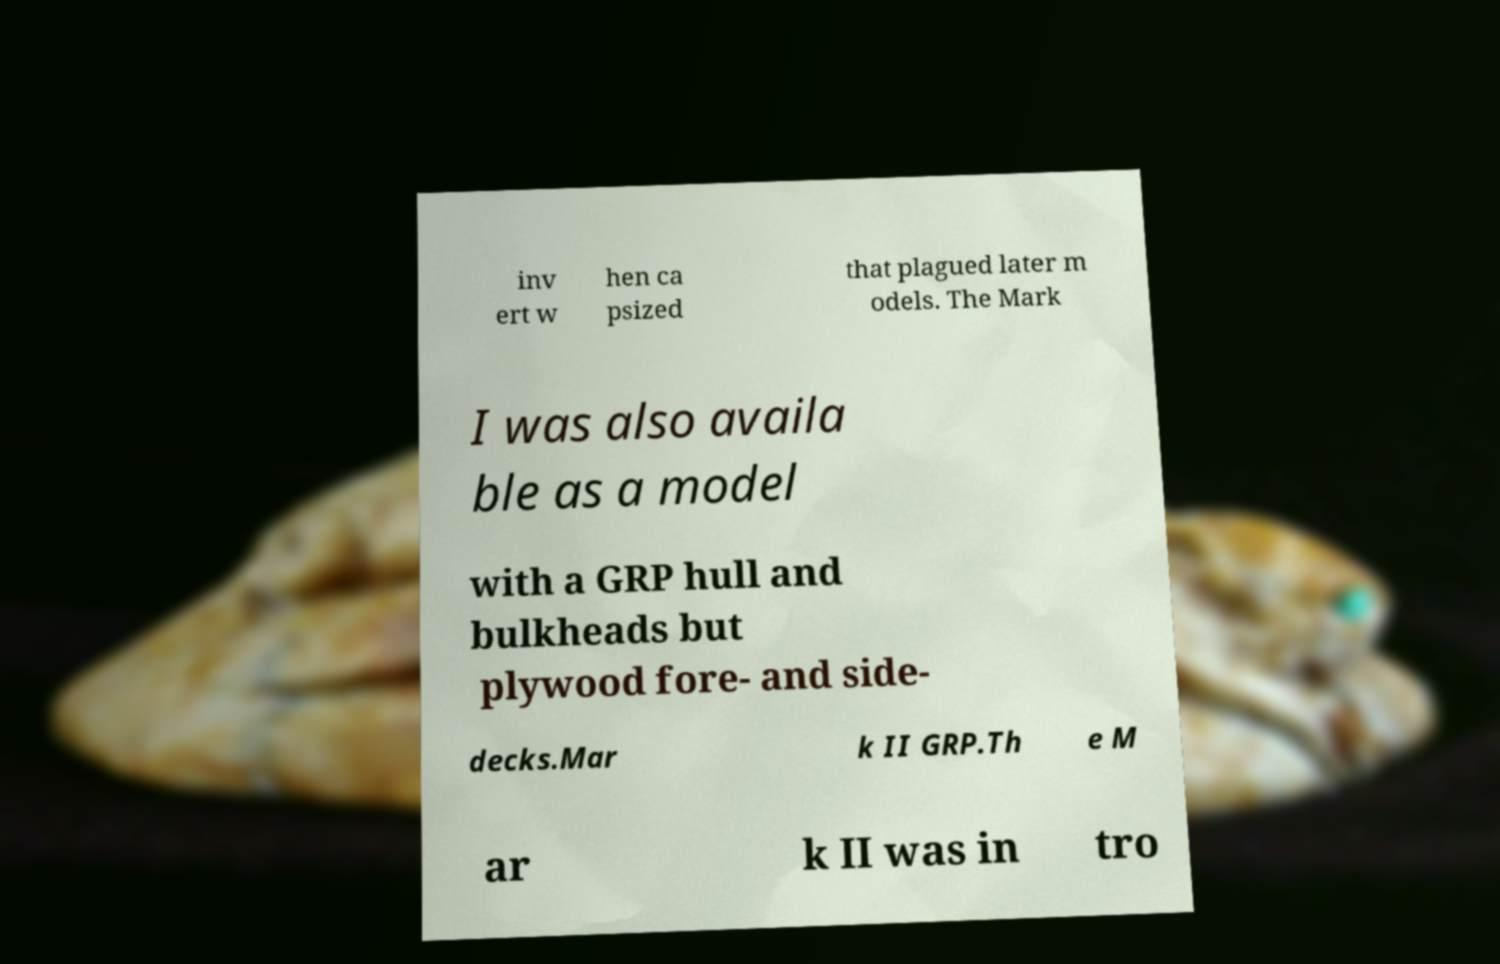What messages or text are displayed in this image? I need them in a readable, typed format. inv ert w hen ca psized that plagued later m odels. The Mark I was also availa ble as a model with a GRP hull and bulkheads but plywood fore- and side- decks.Mar k II GRP.Th e M ar k II was in tro 